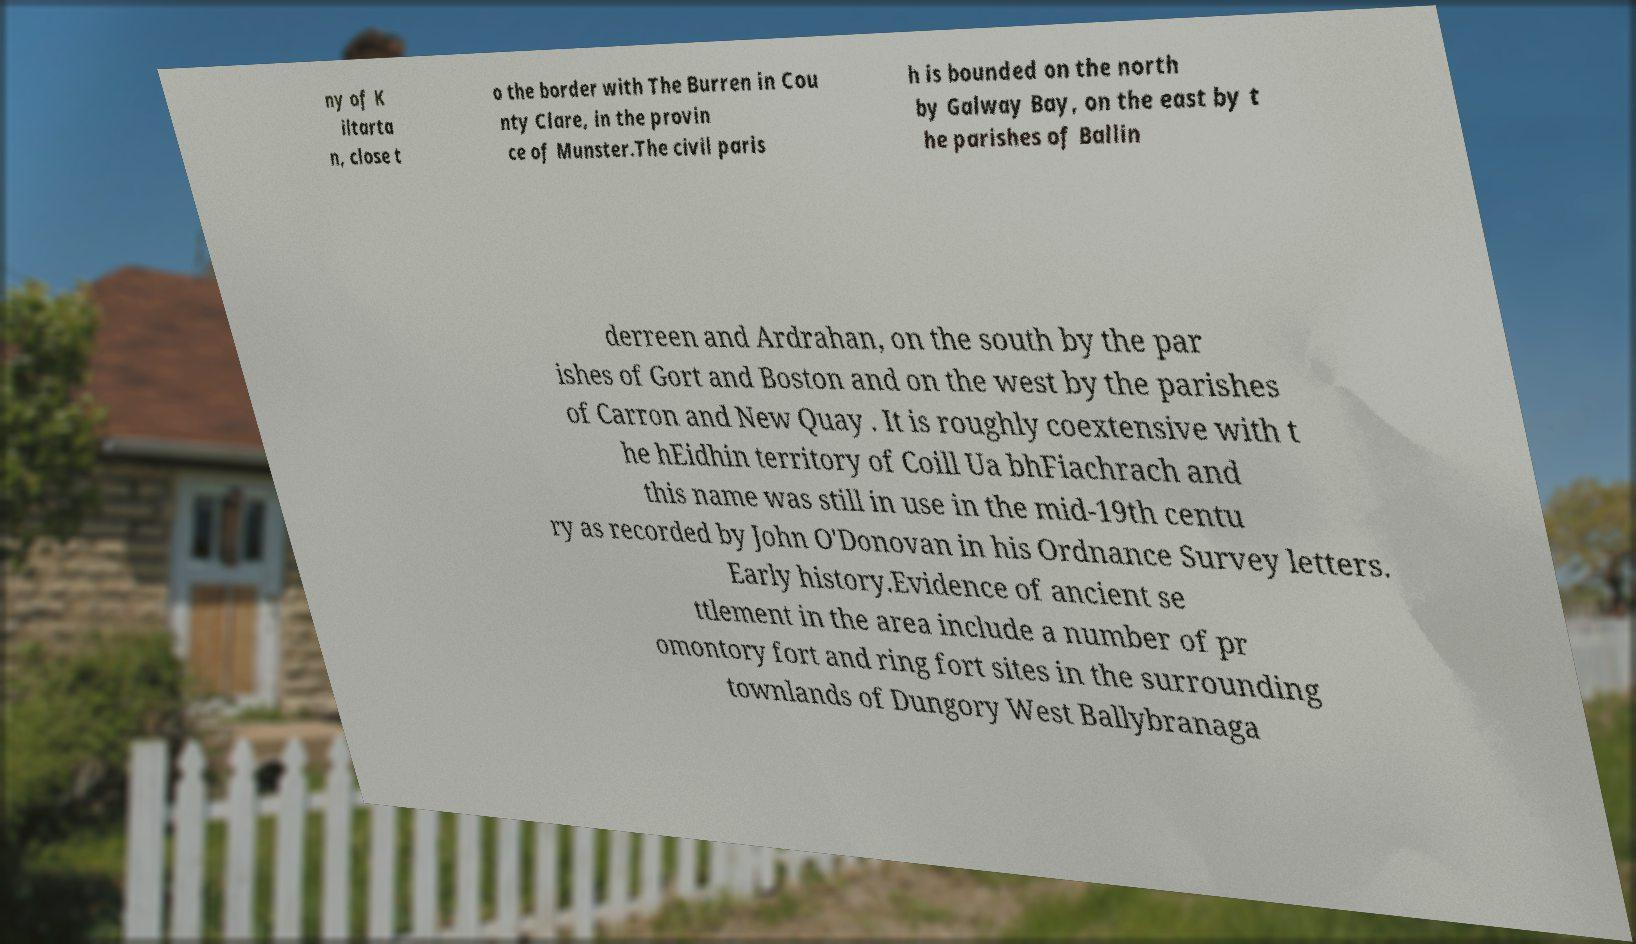Can you read and provide the text displayed in the image?This photo seems to have some interesting text. Can you extract and type it out for me? ny of K iltarta n, close t o the border with The Burren in Cou nty Clare, in the provin ce of Munster.The civil paris h is bounded on the north by Galway Bay, on the east by t he parishes of Ballin derreen and Ardrahan, on the south by the par ishes of Gort and Boston and on the west by the parishes of Carron and New Quay . It is roughly coextensive with t he hEidhin territory of Coill Ua bhFiachrach and this name was still in use in the mid-19th centu ry as recorded by John O'Donovan in his Ordnance Survey letters. Early history.Evidence of ancient se ttlement in the area include a number of pr omontory fort and ring fort sites in the surrounding townlands of Dungory West Ballybranaga 